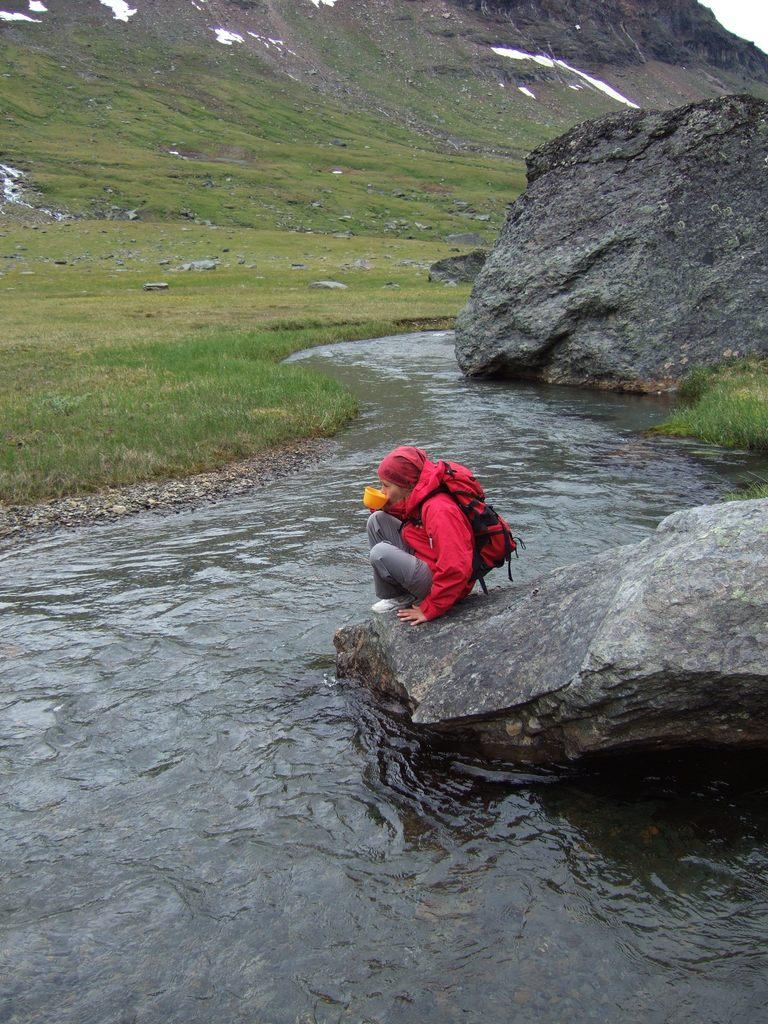What is the setting of the image? The image is an outside view. What body of water is present in the image? There is a lake at the bottom of the image. Can you describe the person in the image? There is a person sitting on a rock on the right side of the image. What type of vegetation is present on the ground in the image? The ground in the background has grass. What geographical feature is visible in the background? There is a hill visible in the background. What color is the eye of the pot in the image? There is no pot or eye present in the image. What type of attraction is visible in the image? There is no attraction visible in the image; it is a natural outdoor scene. 